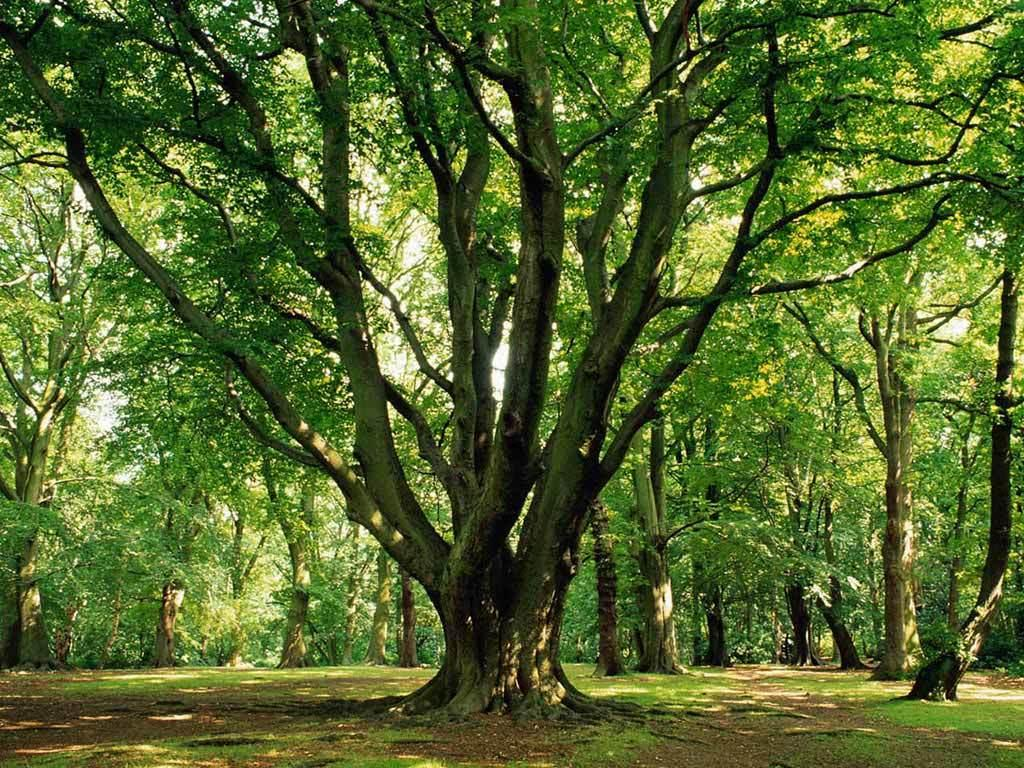What type of vegetation is predominant in the image? There are many trees in the image. What is the ground covered with in the image? The land in the image is grassy. What type of beef can be seen being prepared in the image? There is no beef or any food preparation visible in the image; it primarily features trees and grassy land. 